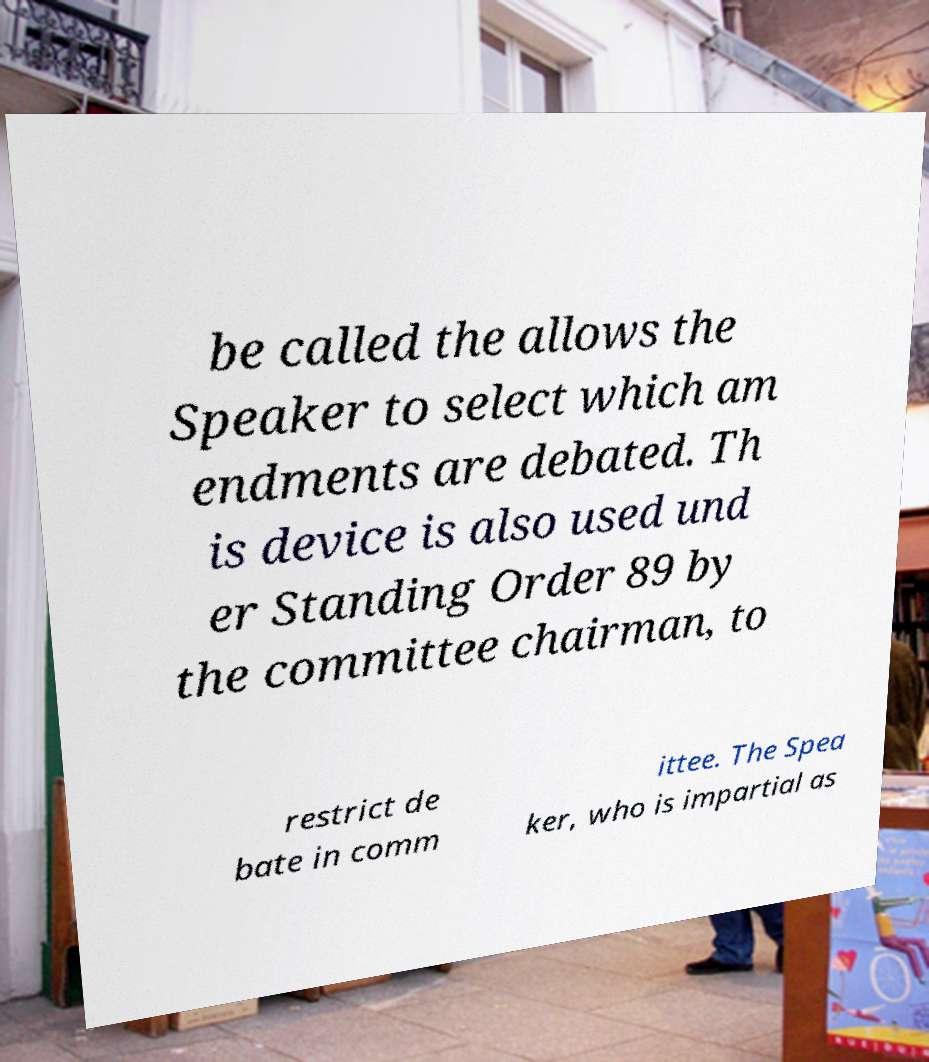There's text embedded in this image that I need extracted. Can you transcribe it verbatim? be called the allows the Speaker to select which am endments are debated. Th is device is also used und er Standing Order 89 by the committee chairman, to restrict de bate in comm ittee. The Spea ker, who is impartial as 